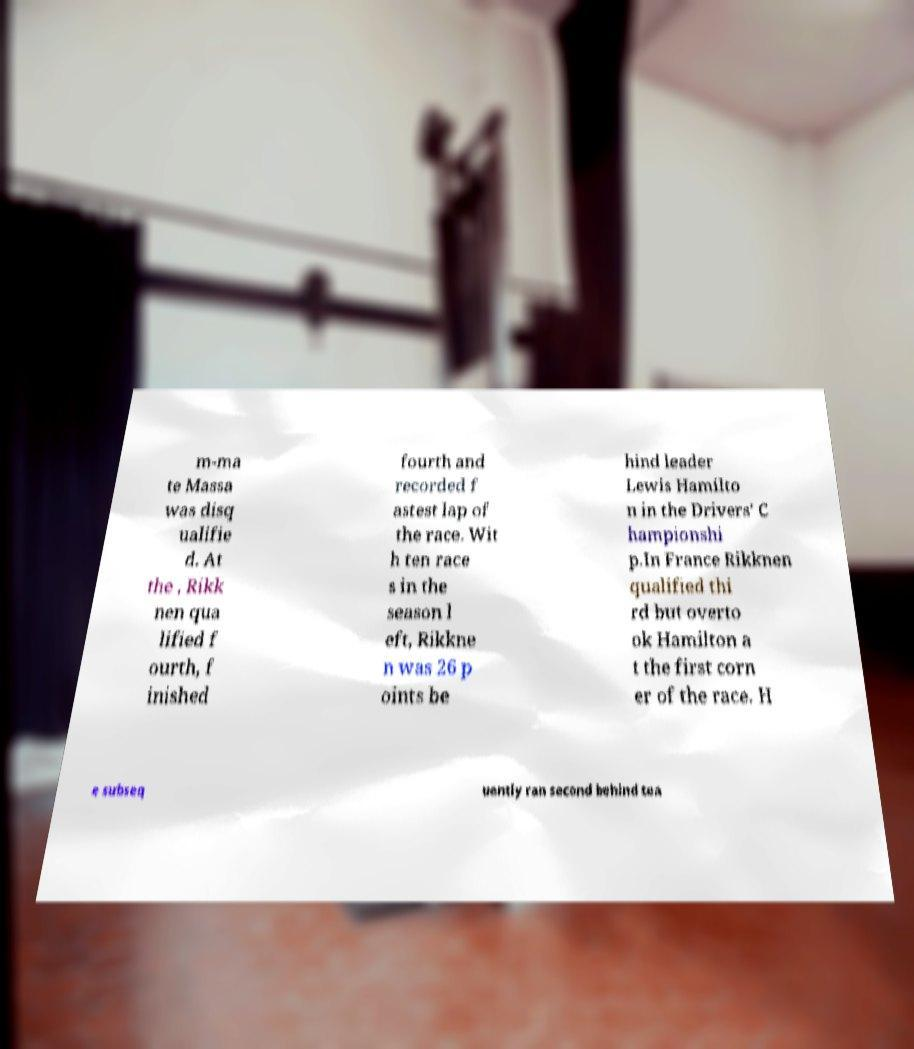I need the written content from this picture converted into text. Can you do that? m-ma te Massa was disq ualifie d. At the , Rikk nen qua lified f ourth, f inished fourth and recorded f astest lap of the race. Wit h ten race s in the season l eft, Rikkne n was 26 p oints be hind leader Lewis Hamilto n in the Drivers' C hampionshi p.In France Rikknen qualified thi rd but overto ok Hamilton a t the first corn er of the race. H e subseq uently ran second behind tea 